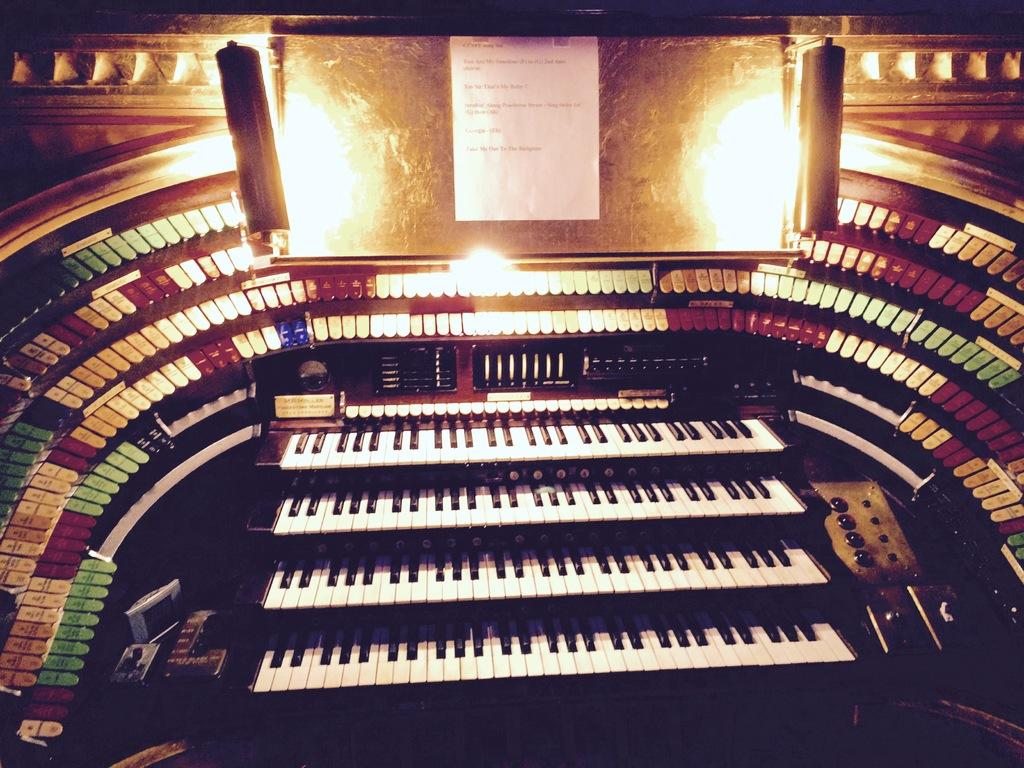What type of living organisms can be seen in the image? Plants can be seen in the image. What is attached to the board in the image? There is a paper attached to a board in the image. What type of jelly can be seen dripping from the plants in the image? There is no jelly present in the image; it features plants and a paper attached to a board. What type of verse is written on the paper in the image? There is no information about the content of the paper in the image, so we cannot determine if it contains a verse. 